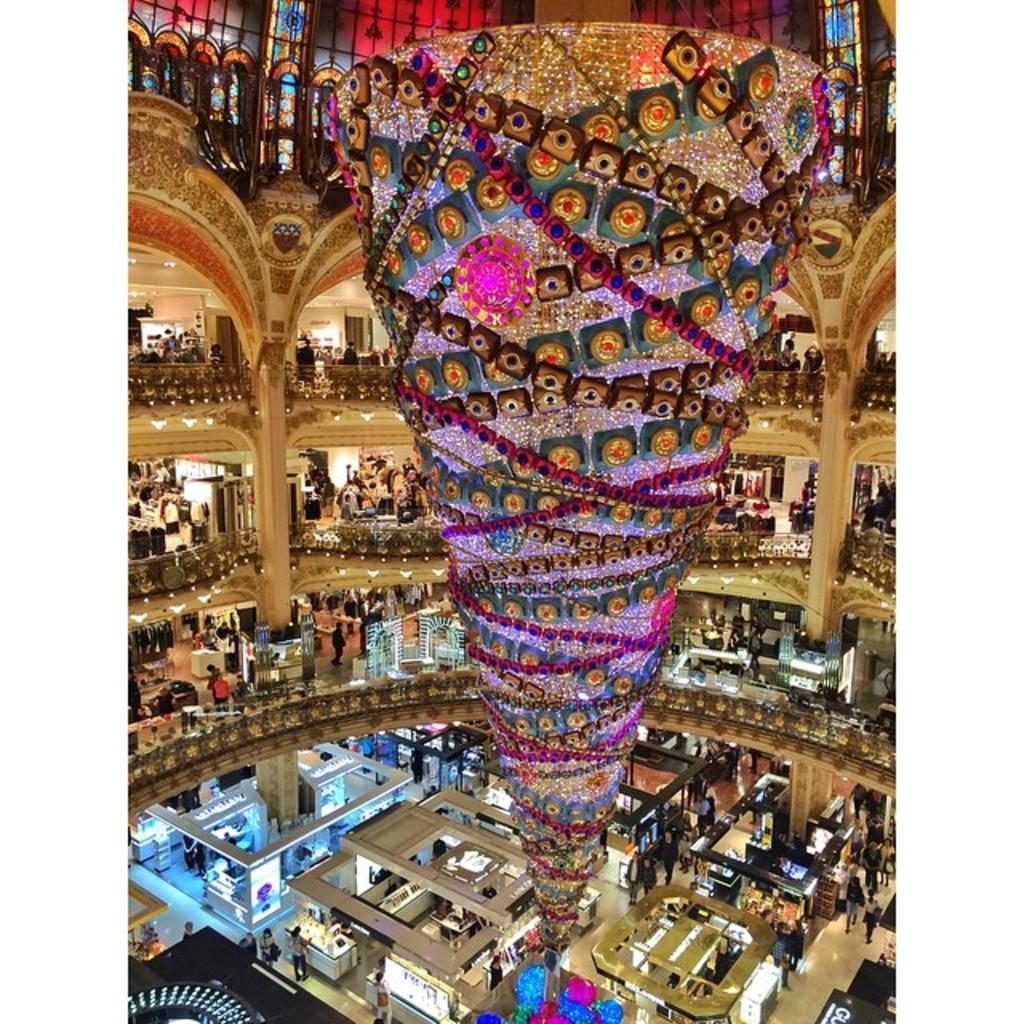How would you summarize this image in a sentence or two? In this picture we can see an inside view of a building, we can see railings here, there are some people standing here, at the bottom we can see some people, there are some stores here, we can see decorative things here. 